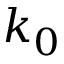Convert formula to latex. <formula><loc_0><loc_0><loc_500><loc_500>k _ { 0 }</formula> 